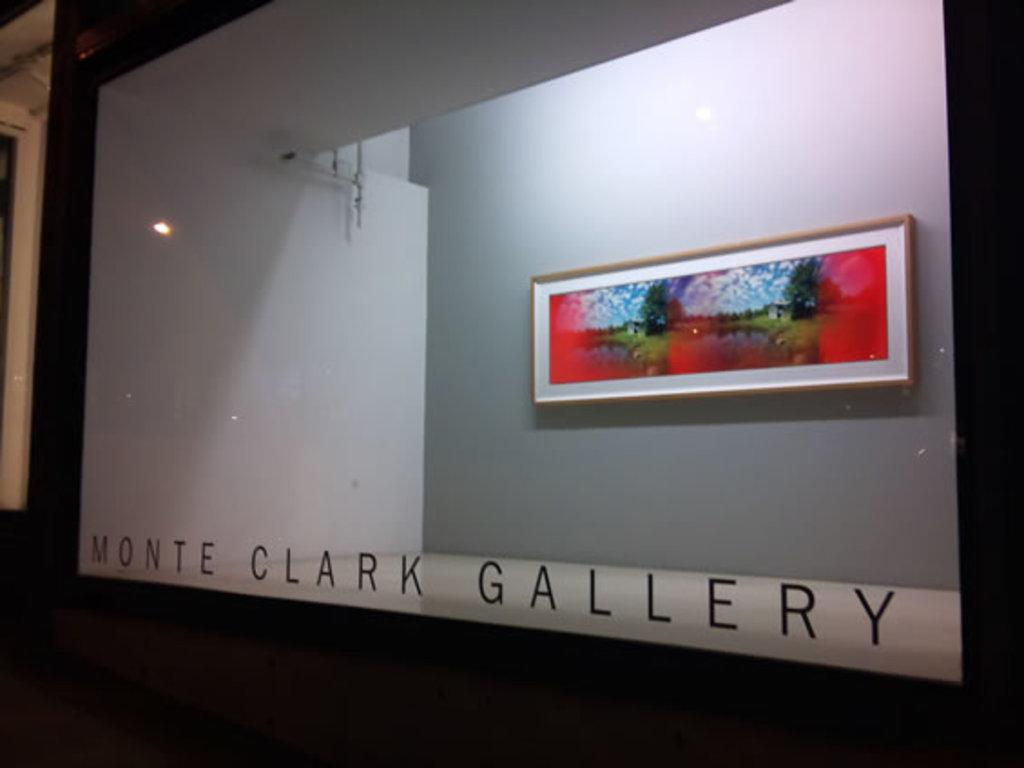Provide a one-sentence caption for the provided image. A rectagular piece of artwork on display behind a glass window with Monte Clark Gallery on the window. 